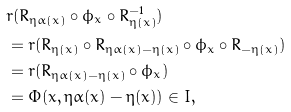<formula> <loc_0><loc_0><loc_500><loc_500>& r ( R _ { \eta \alpha ( x ) } \circ \phi _ { x } \circ R _ { \eta ( x ) } ^ { - 1 } ) \\ & = r ( R _ { \eta ( x ) } \circ R _ { \eta \alpha ( x ) - \eta ( x ) } \circ \phi _ { x } \circ R _ { - \eta ( x ) } ) \\ & = r ( R _ { \eta \alpha ( x ) - \eta ( x ) } \circ \phi _ { x } ) \\ & = \Phi ( x , \eta \alpha ( x ) - \eta ( x ) ) \in I ,</formula> 